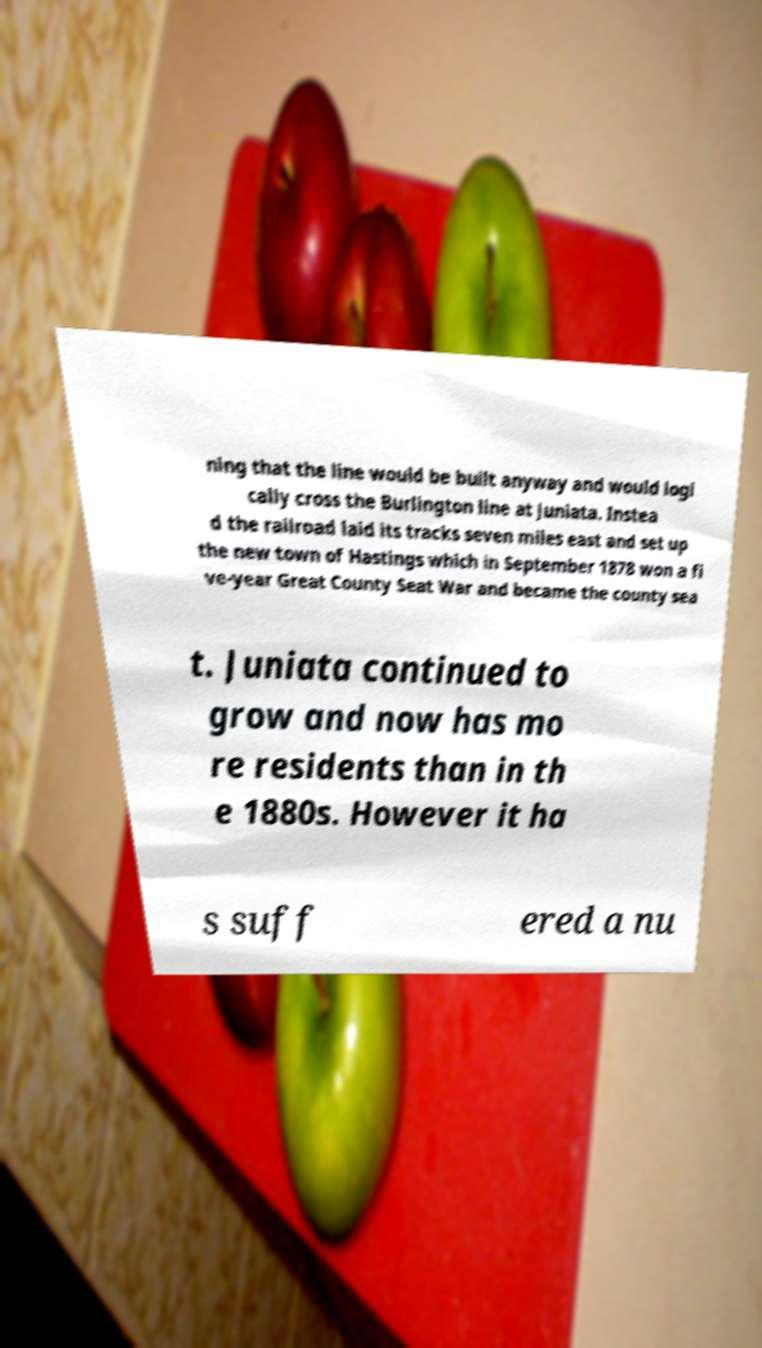For documentation purposes, I need the text within this image transcribed. Could you provide that? ning that the line would be built anyway and would logi cally cross the Burlington line at Juniata. Instea d the railroad laid its tracks seven miles east and set up the new town of Hastings which in September 1878 won a fi ve-year Great County Seat War and became the county sea t. Juniata continued to grow and now has mo re residents than in th e 1880s. However it ha s suff ered a nu 